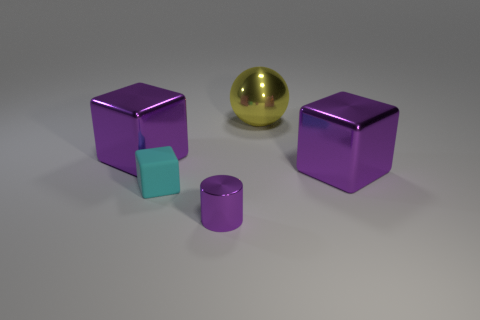The big object that is behind the purple metal block that is left of the large metallic cube that is to the right of the small matte block is what color?
Keep it short and to the point. Yellow. Is there anything else of the same color as the cylinder?
Provide a succinct answer. Yes. There is a yellow shiny thing right of the cyan block; how big is it?
Offer a very short reply. Large. What shape is the shiny object that is the same size as the cyan rubber thing?
Your answer should be very brief. Cylinder. Is the large purple thing on the left side of the matte cube made of the same material as the block right of the tiny purple metal cylinder?
Give a very brief answer. Yes. The big object behind the large purple thing that is left of the yellow ball is made of what material?
Keep it short and to the point. Metal. How big is the purple cube that is to the left of the big purple metallic cube right of the big purple metal cube that is left of the purple cylinder?
Provide a short and direct response. Large. Do the purple metallic cylinder and the cyan thing have the same size?
Your answer should be very brief. Yes. Do the large purple thing on the left side of the cyan rubber cube and the large purple metal thing that is right of the small cyan rubber object have the same shape?
Provide a short and direct response. Yes. Is there a metallic cube behind the purple object right of the metal cylinder?
Your answer should be compact. Yes. 